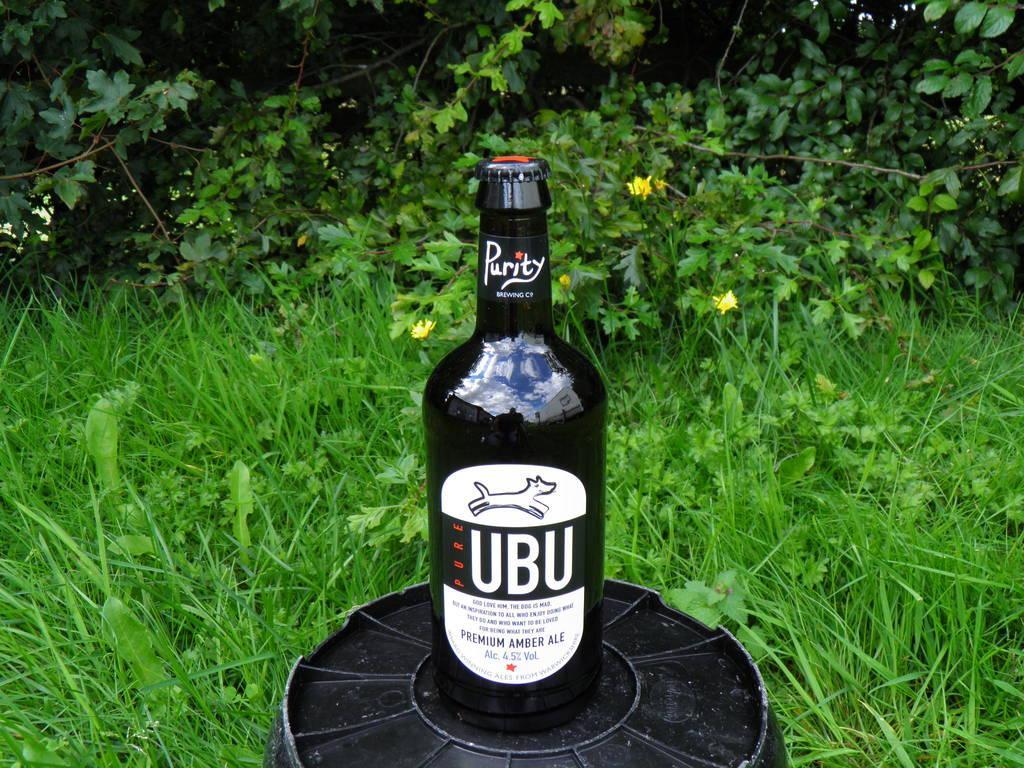How would you summarize this image in a sentence or two? There is a black color bottle on which, there is a sticker pasted, on a black color object. Beside this object, there are plants and grass on the ground. In the background, there are trees. 